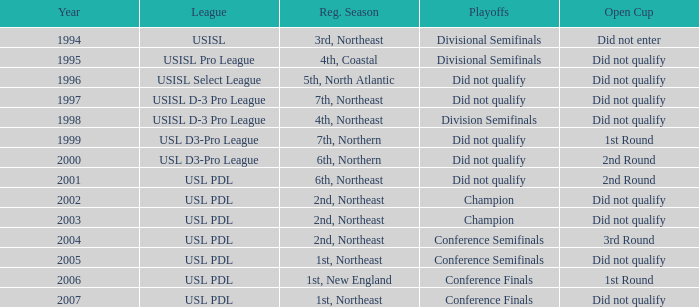How many years in total does the usl pro league encompass? 1.0. 